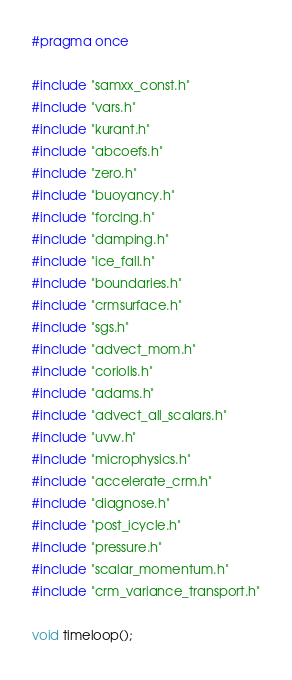<code> <loc_0><loc_0><loc_500><loc_500><_C_>
#pragma once

#include "samxx_const.h"
#include "vars.h"
#include "kurant.h"
#include "abcoefs.h"
#include "zero.h"
#include "buoyancy.h"
#include "forcing.h"
#include "damping.h"
#include "ice_fall.h"
#include "boundaries.h"
#include "crmsurface.h"
#include "sgs.h"
#include "advect_mom.h"
#include "coriolis.h"
#include "adams.h"
#include "advect_all_scalars.h"
#include "uvw.h"
#include "microphysics.h"
#include "accelerate_crm.h"
#include "diagnose.h"
#include "post_icycle.h"
#include "pressure.h"
#include "scalar_momentum.h"
#include "crm_variance_transport.h"

void timeloop();

</code> 